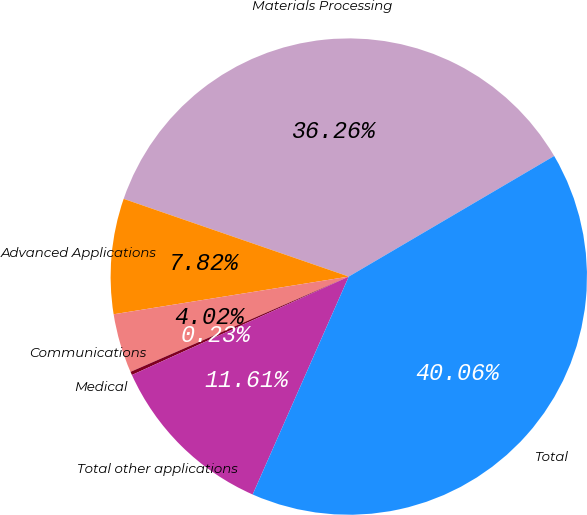Convert chart. <chart><loc_0><loc_0><loc_500><loc_500><pie_chart><fcel>Materials Processing<fcel>Advanced Applications<fcel>Communications<fcel>Medical<fcel>Total other applications<fcel>Total<nl><fcel>36.26%<fcel>7.82%<fcel>4.02%<fcel>0.23%<fcel>11.61%<fcel>40.06%<nl></chart> 